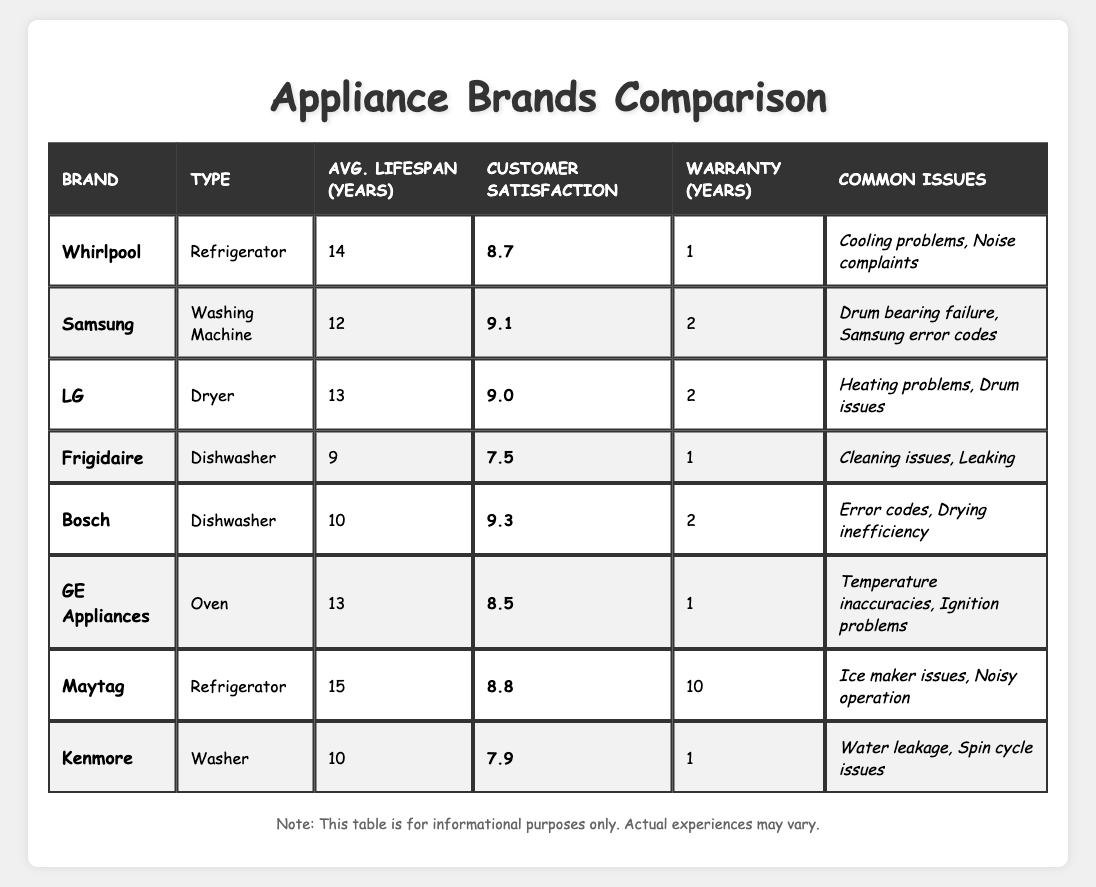What is the average lifespan of a Maytag refrigerator? The table lists Maytag under refrigerators with an average lifespan of 15 years.
Answer: 15 years Which brand has the highest customer satisfaction rating? The table shows that Bosch has the highest customer satisfaction rating at 9.3.
Answer: Bosch Is the warranty period for Samsung washing machine longer than that of Whirlpool refrigerator? Samsung has a warranty of 2 years, while Whirlpool has a warranty of 1 year, so yes, Samsung's is longer.
Answer: Yes What is the difference in average lifespan between Frigidaire and LG? Frigidaire has an average lifespan of 9 years and LG has 13 years. The difference is 13 - 9 = 4 years.
Answer: 4 years How many brands have an average lifespan of 13 years or more? The brands with 13 or more years are Maytag (15), Whirlpool (14), and LG (13), totaling 3 brands.
Answer: 3 brands Does Kenmore have a higher customer satisfaction rating than Frigidaire? Kenmore has a rating of 7.9 and Frigidaire has 7.5, so Kenmore has a higher rating.
Answer: Yes What is the average customer satisfaction rating for the dishwashers listed? Bosch has 9.3 and Frigidaire has 7.5. Average = (9.3 + 7.5) / 2 = 8.4.
Answer: 8.4 Are any brands listed without common issues? All brands listed have common issues mentioned, so the answer is no.
Answer: No What is the total warranty period of the appliances listed by Maytag? Maytag has a warranty period of 10 years for its refrigerator, which is the only appliance listed under this brand.
Answer: 10 years If you combine the average lifespan of the LG dryer and GE oven, what do you get? LG has an average lifespan of 13 years and GE has 13 years; adding them gives 13 + 13 = 26 years.
Answer: 26 years 